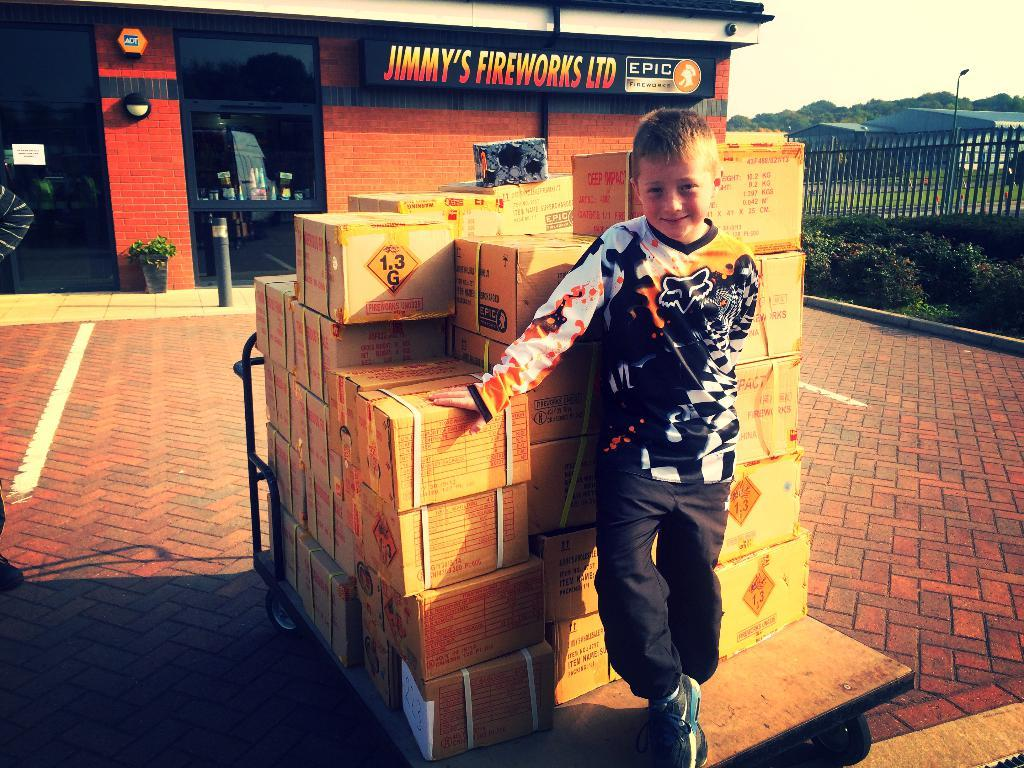Provide a one-sentence caption for the provided image. A small blonde boy is standing in front of boxes of fireworks at Jimmy's fireworks LTD. 